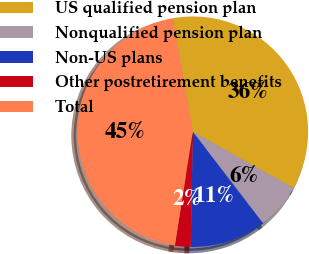Convert chart to OTSL. <chart><loc_0><loc_0><loc_500><loc_500><pie_chart><fcel>US qualified pension plan<fcel>Nonqualified pension plan<fcel>Non-US plans<fcel>Other postretirement benefits<fcel>Total<nl><fcel>35.91%<fcel>6.45%<fcel>10.71%<fcel>2.2%<fcel>44.72%<nl></chart> 